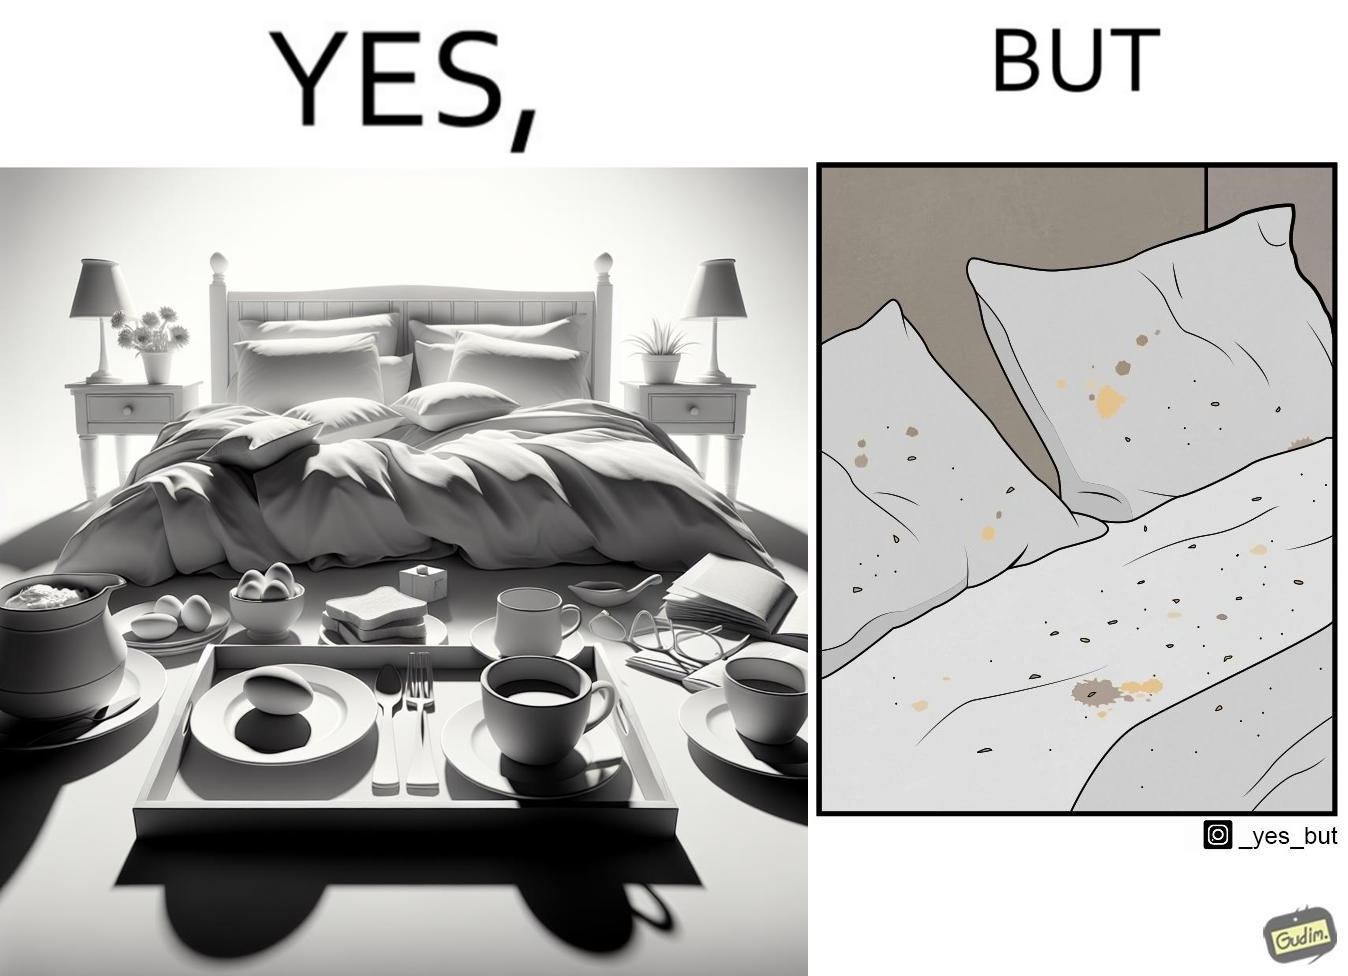What is shown in this image? The image is ironical, as having breakfast in bed is a luxury. However, eating while in bed leads to food crumbs, making the bed dirty, along with the need to clean the bed afterwards. 